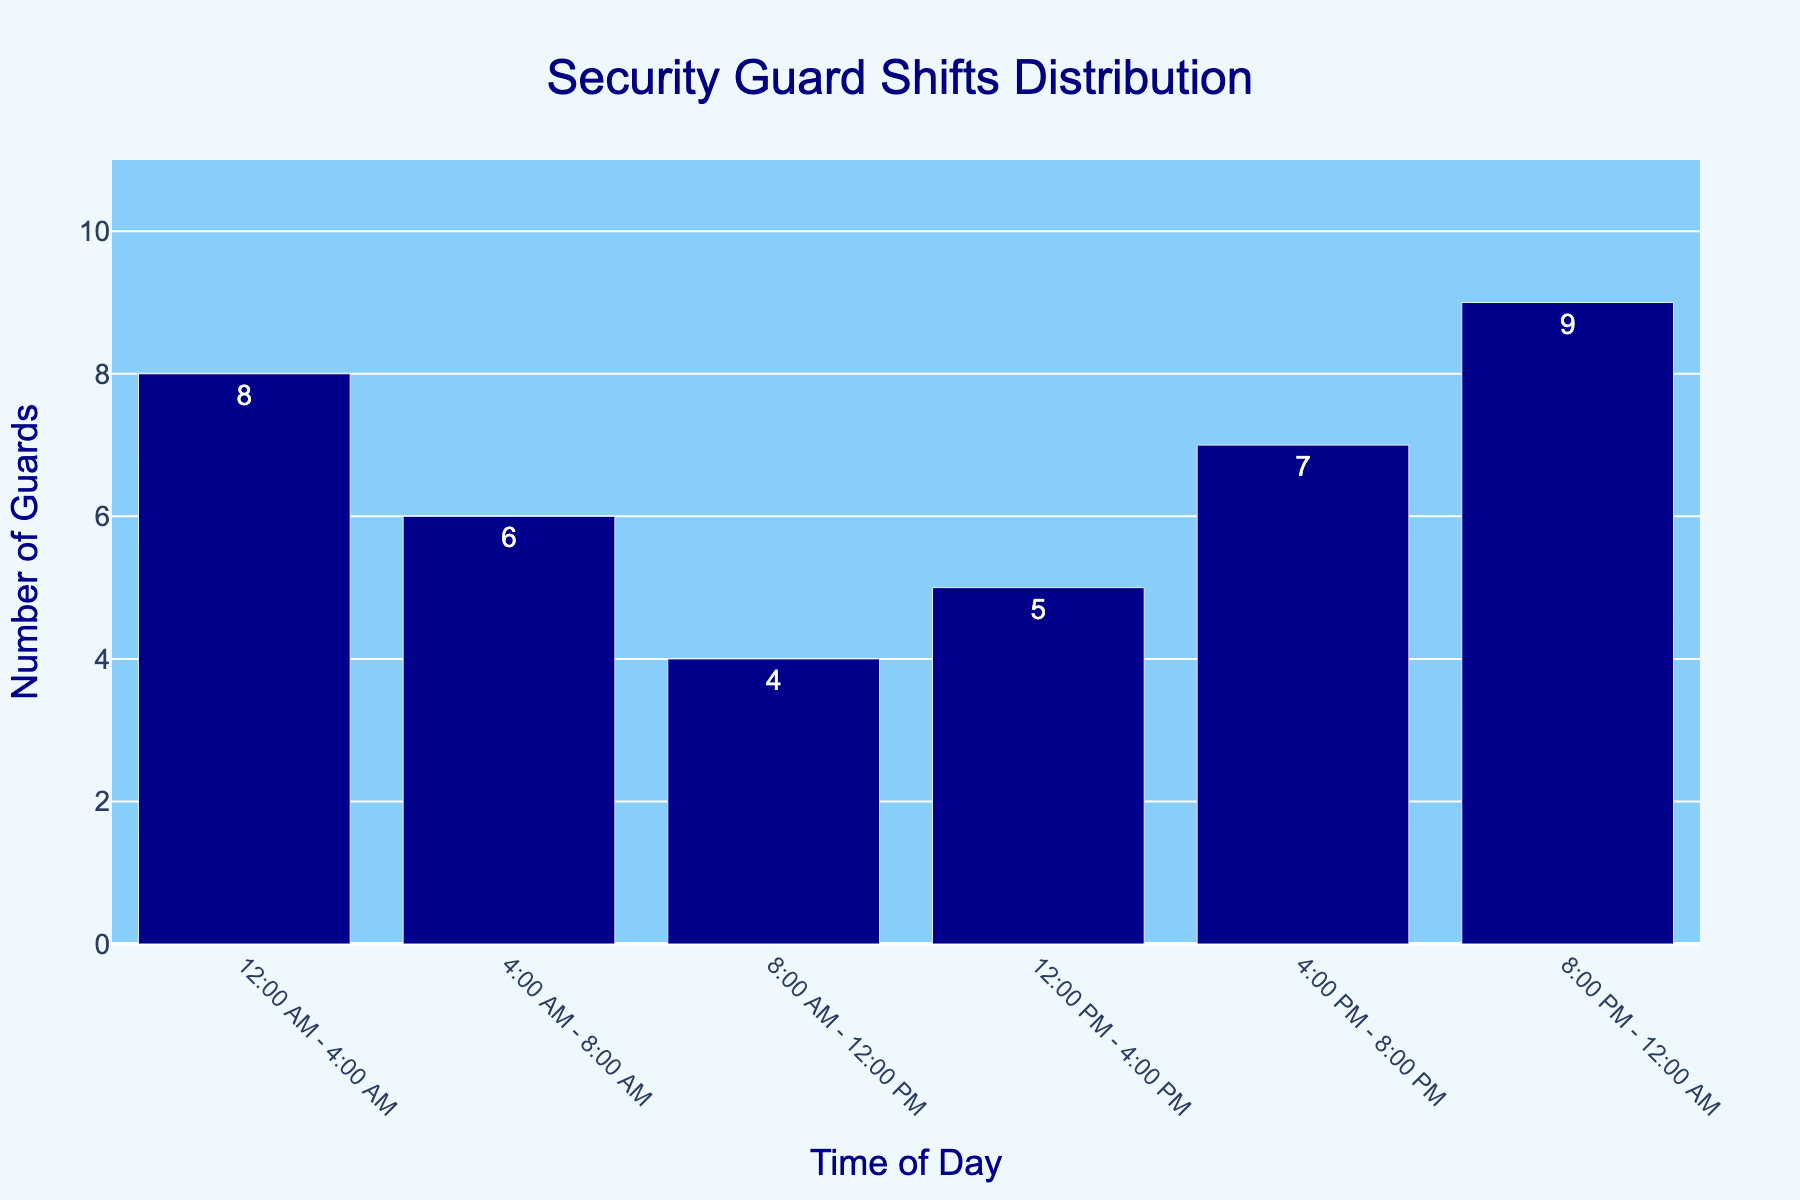What time of day has the highest number of guards on shift? Identify the bar with the greatest height, which represents the highest number of guards on shift.
Answer: 8:00 PM - 12:00 AM How many guards are on shift between 4:00 AM and 8:00 AM? Locate the bar labeled "4:00 AM - 8:00 AM" and read the corresponding number.
Answer: 6 During which time period are the fewest guards on shift? Identify the bar with the smallest height, indicating the lowest number of guards on shift.
Answer: 8:00 AM - 12:00 PM How does the number of guards on shift from 12:00 PM to 4:00 PM compare to the number on shift from 4:00 PM to 8:00 PM? Compare the heights of the bars labeled "12:00 PM - 4:00 PM" and "4:00 PM - 8:00 PM" to see which is taller.
Answer: Less What's the total number of guards on shift from 12:00 AM to 12:00 PM? Sum the number of guards for the time slots "12:00 AM - 4:00 AM", "4:00 AM - 8:00 AM", and "8:00 AM - 12:00 PM".
Answer: 18 What is the visual difference between the number of guards on shift from 8:00 PM to 12:00 AM and 12:00 PM to 4:00 PM? Compare the height difference of the two bars representing the shifts; 9 guards for "8:00 PM - 12:00 AM" and 5 guards for "12:00 PM - 4:00 PM".
Answer: 4 guards higher Which time period has exactly one more guard than the 8:00 AM - 12:00 PM shift? Read the data for "8:00 AM - 12:00 PM" which is 4 guards, then identify the time slot with 5 guards.
Answer: 12:00 PM - 4:00 PM How many guards are working between 8:00 AM and 8:00 PM? Sum the number of guards for the time slots "8:00 AM - 12:00 PM", "12:00 PM - 4:00 PM", and "4:00 PM - 8:00 PM".
Answer: 16 Which time slot has the second highest number of guards on shift? Identify the bar with the second greatest number, which appears after the highest number of 9 guards for "8:00 PM - 12:00 AM".
Answer: 12:00 AM - 4:00 AM 